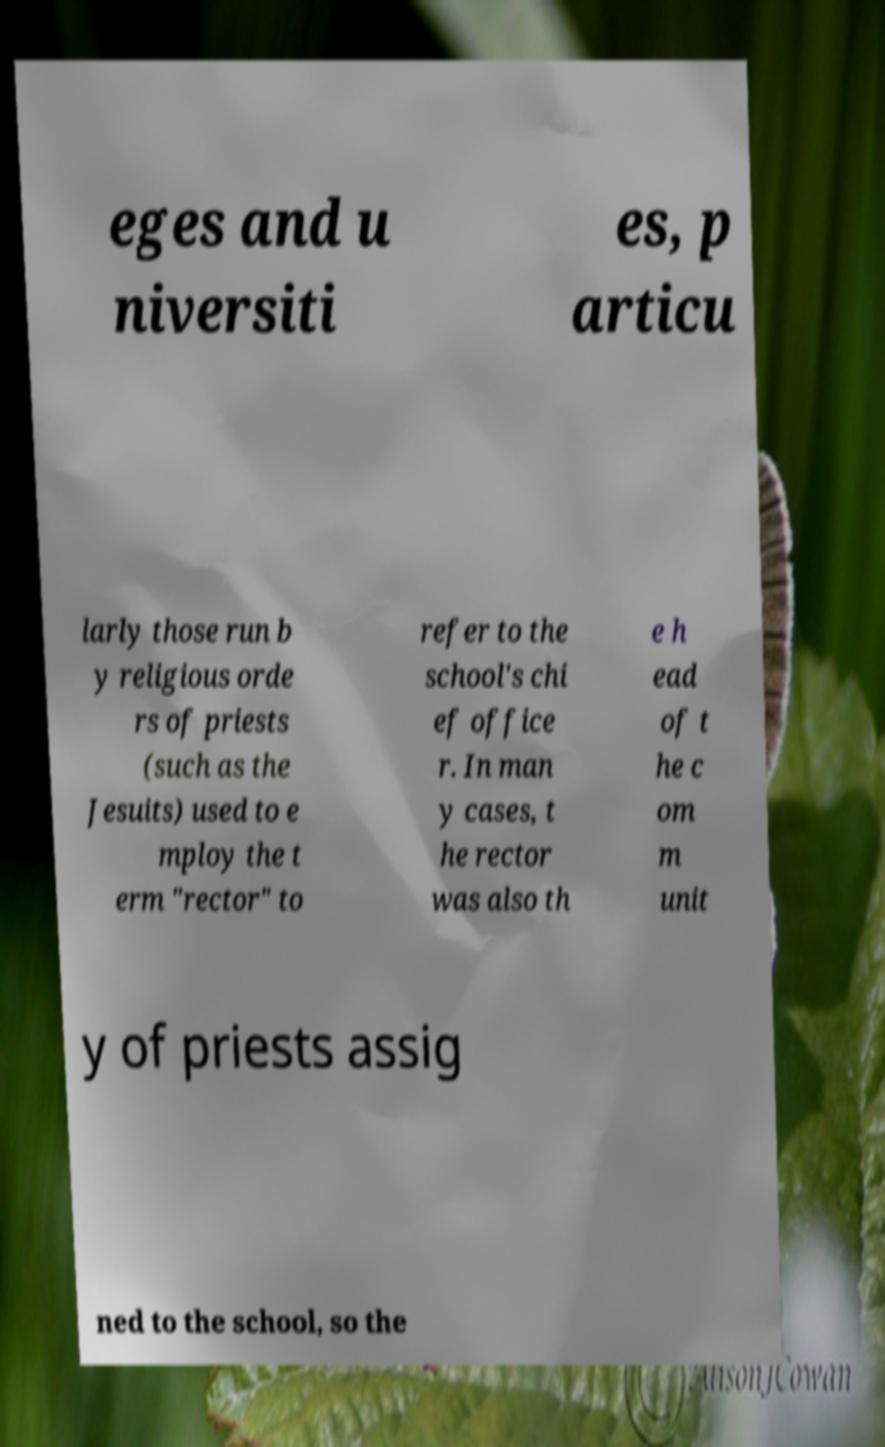Please identify and transcribe the text found in this image. eges and u niversiti es, p articu larly those run b y religious orde rs of priests (such as the Jesuits) used to e mploy the t erm "rector" to refer to the school's chi ef office r. In man y cases, t he rector was also th e h ead of t he c om m unit y of priests assig ned to the school, so the 